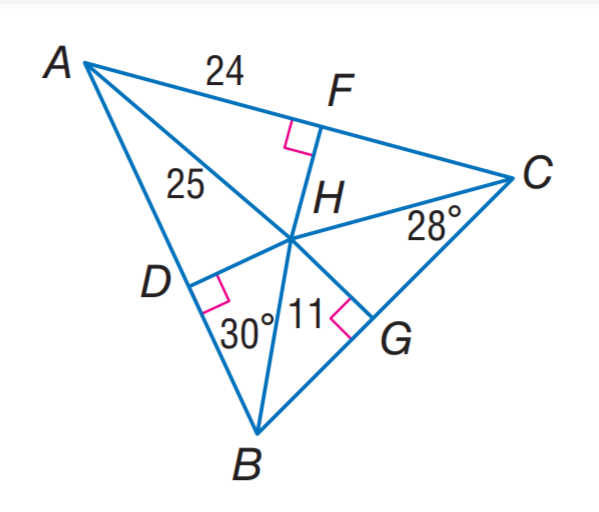Answer the mathemtical geometry problem and directly provide the correct option letter.
Question: H is the incenter of \triangle A B C. Find D H.
Choices: A: 7 B: 11 C: 24 D: 25 A 